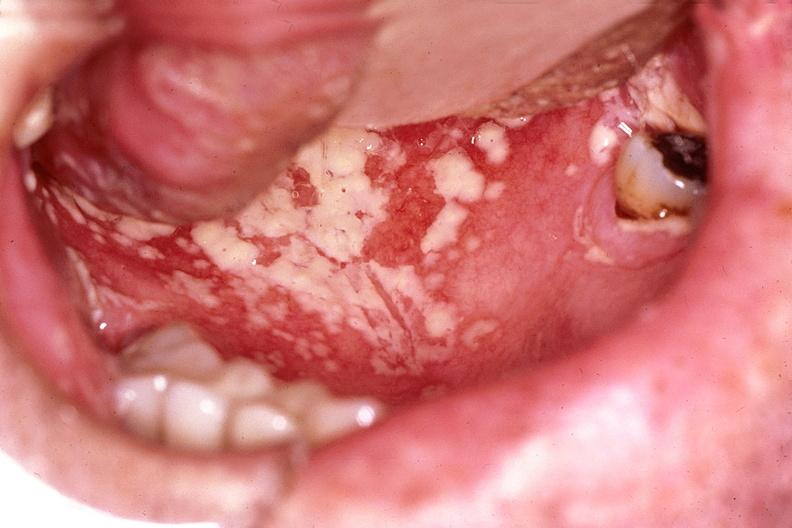what does this image show?
Answer the question using a single word or phrase. Mouth 